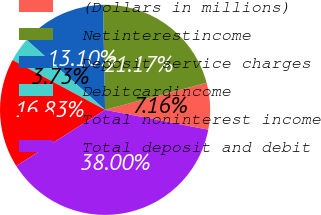<chart> <loc_0><loc_0><loc_500><loc_500><pie_chart><fcel>(Dollars in millions)<fcel>Netinterestincome<fcel>Deposit service charges<fcel>Debitcardincome<fcel>Total noninterest income<fcel>Total deposit and debit<nl><fcel>7.16%<fcel>21.17%<fcel>13.1%<fcel>3.73%<fcel>16.83%<fcel>38.0%<nl></chart> 